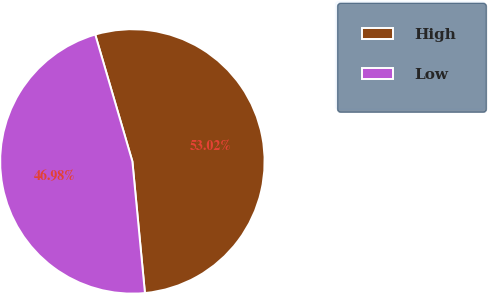Convert chart. <chart><loc_0><loc_0><loc_500><loc_500><pie_chart><fcel>High<fcel>Low<nl><fcel>53.02%<fcel>46.98%<nl></chart> 